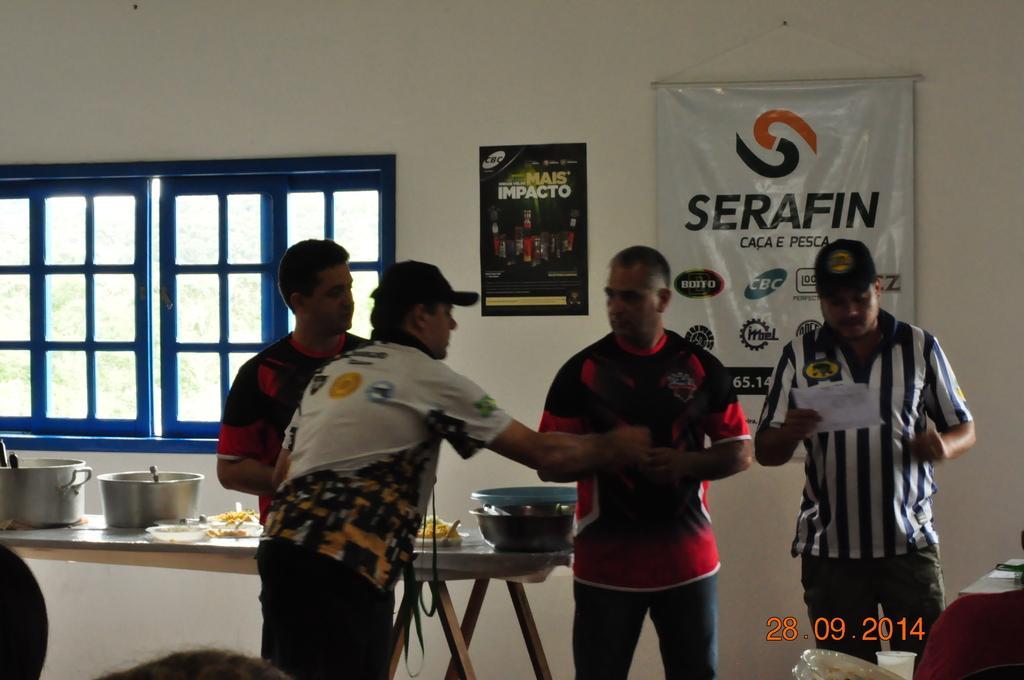Describe this image in one or two sentences. This picture is clicked inside the room. In this picture, we see four men are standing. Behind them, we see a table on which plates containing foods, spoons and vessels are placed. Behind them, we see a white wall on which a poster and a banner in white color with text written on it are placed. On the left side, we see a window from which we can see trees. 